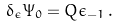<formula> <loc_0><loc_0><loc_500><loc_500>\delta _ { \epsilon } \Psi _ { 0 } = Q \epsilon _ { - 1 } \, .</formula> 